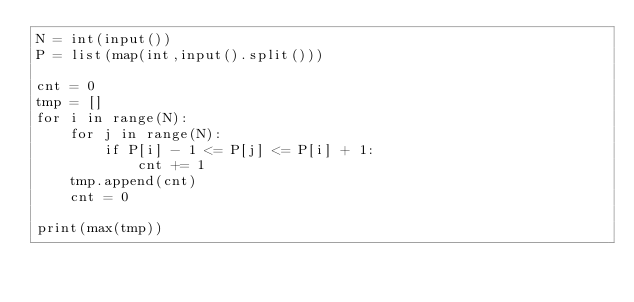<code> <loc_0><loc_0><loc_500><loc_500><_Python_>N = int(input())
P = list(map(int,input().split()))

cnt = 0
tmp = []
for i in range(N):
    for j in range(N):
        if P[i] - 1 <= P[j] <= P[i] + 1:
            cnt += 1
    tmp.append(cnt)
    cnt = 0

print(max(tmp))</code> 